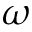Convert formula to latex. <formula><loc_0><loc_0><loc_500><loc_500>\omega</formula> 